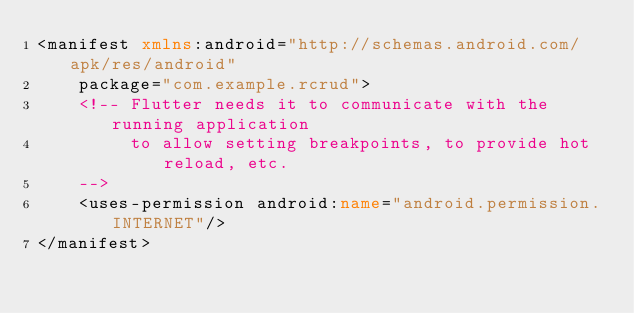<code> <loc_0><loc_0><loc_500><loc_500><_XML_><manifest xmlns:android="http://schemas.android.com/apk/res/android"
    package="com.example.rcrud">
    <!-- Flutter needs it to communicate with the running application
         to allow setting breakpoints, to provide hot reload, etc.
    -->
    <uses-permission android:name="android.permission.INTERNET"/>
</manifest>
</code> 